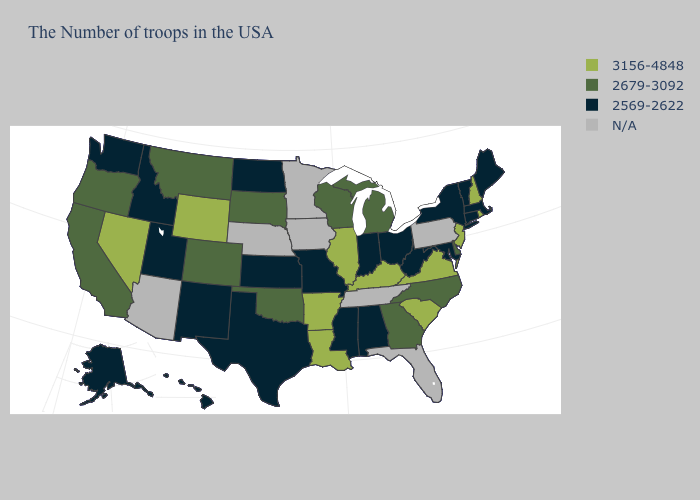What is the value of California?
Concise answer only. 2679-3092. Does Vermont have the lowest value in the Northeast?
Short answer required. Yes. What is the value of Hawaii?
Concise answer only. 2569-2622. Name the states that have a value in the range N/A?
Quick response, please. Pennsylvania, Florida, Tennessee, Minnesota, Iowa, Nebraska, Arizona. Does Missouri have the highest value in the MidWest?
Answer briefly. No. Name the states that have a value in the range 2679-3092?
Quick response, please. Delaware, North Carolina, Georgia, Michigan, Wisconsin, Oklahoma, South Dakota, Colorado, Montana, California, Oregon. What is the lowest value in states that border Mississippi?
Write a very short answer. 2569-2622. Among the states that border Mississippi , does Alabama have the highest value?
Answer briefly. No. What is the value of New York?
Short answer required. 2569-2622. What is the value of North Carolina?
Short answer required. 2679-3092. What is the value of New Jersey?
Keep it brief. 3156-4848. Does North Dakota have the highest value in the USA?
Quick response, please. No. Which states have the lowest value in the USA?
Give a very brief answer. Maine, Massachusetts, Vermont, Connecticut, New York, Maryland, West Virginia, Ohio, Indiana, Alabama, Mississippi, Missouri, Kansas, Texas, North Dakota, New Mexico, Utah, Idaho, Washington, Alaska, Hawaii. 